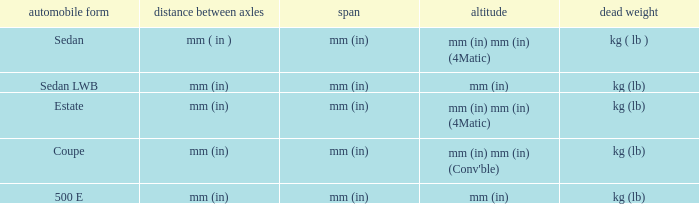What are the lengths of the models that are mm (in) tall? Mm (in), mm (in). 